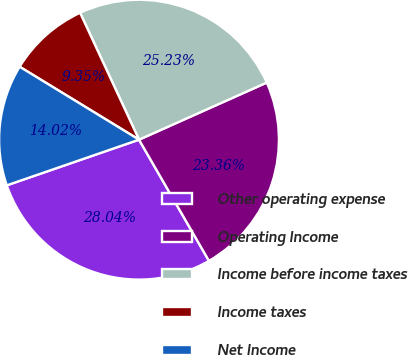Convert chart to OTSL. <chart><loc_0><loc_0><loc_500><loc_500><pie_chart><fcel>Other operating expense<fcel>Operating Income<fcel>Income before income taxes<fcel>Income taxes<fcel>Net Income<nl><fcel>28.04%<fcel>23.36%<fcel>25.23%<fcel>9.35%<fcel>14.02%<nl></chart> 